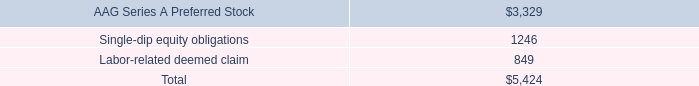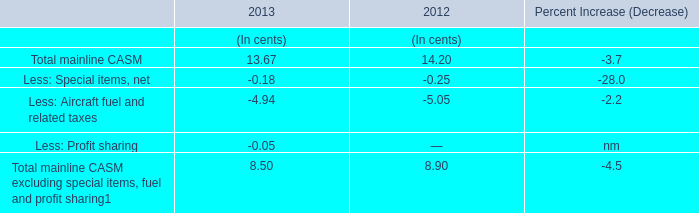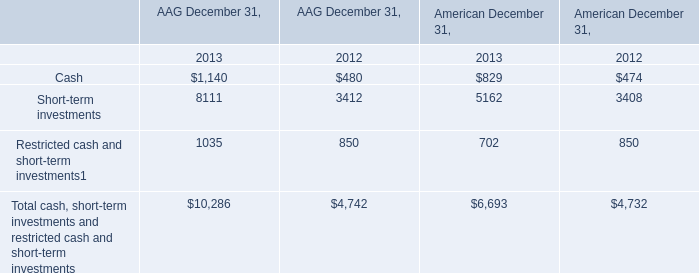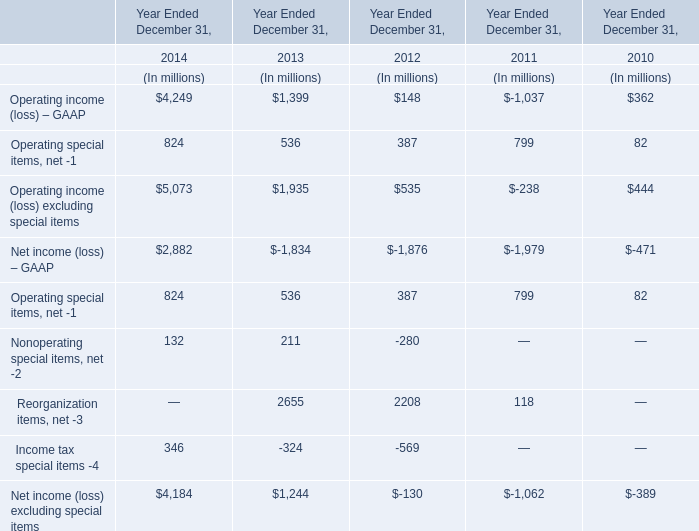Without Operating special items, net and Nonoperating special items, net, how much of Share-based plans expense is there in total in 2013? (in million) 
Computations: (2655 + -324)
Answer: 2331.0. 